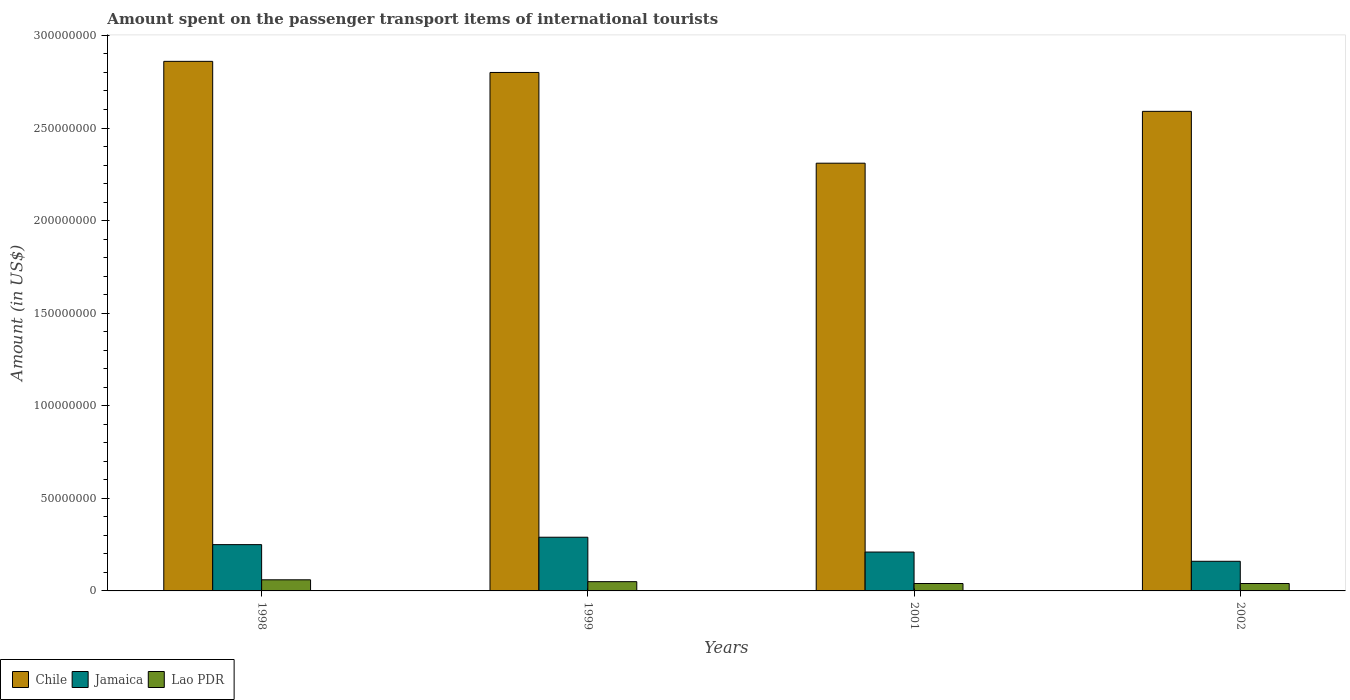How many groups of bars are there?
Your answer should be very brief. 4. How many bars are there on the 2nd tick from the left?
Your answer should be compact. 3. How many bars are there on the 1st tick from the right?
Offer a very short reply. 3. In how many cases, is the number of bars for a given year not equal to the number of legend labels?
Keep it short and to the point. 0. What is the amount spent on the passenger transport items of international tourists in Chile in 1999?
Your answer should be very brief. 2.80e+08. In which year was the amount spent on the passenger transport items of international tourists in Chile maximum?
Offer a terse response. 1998. What is the total amount spent on the passenger transport items of international tourists in Chile in the graph?
Make the answer very short. 1.06e+09. What is the difference between the amount spent on the passenger transport items of international tourists in Chile in 1999 and that in 2002?
Offer a terse response. 2.10e+07. What is the difference between the amount spent on the passenger transport items of international tourists in Lao PDR in 1998 and the amount spent on the passenger transport items of international tourists in Jamaica in 2001?
Provide a succinct answer. -1.50e+07. What is the average amount spent on the passenger transport items of international tourists in Jamaica per year?
Your response must be concise. 2.28e+07. In the year 2001, what is the difference between the amount spent on the passenger transport items of international tourists in Chile and amount spent on the passenger transport items of international tourists in Jamaica?
Your response must be concise. 2.10e+08. Is the difference between the amount spent on the passenger transport items of international tourists in Chile in 1998 and 2001 greater than the difference between the amount spent on the passenger transport items of international tourists in Jamaica in 1998 and 2001?
Provide a short and direct response. Yes. What is the difference between the highest and the lowest amount spent on the passenger transport items of international tourists in Jamaica?
Make the answer very short. 1.30e+07. Is the sum of the amount spent on the passenger transport items of international tourists in Jamaica in 1999 and 2002 greater than the maximum amount spent on the passenger transport items of international tourists in Chile across all years?
Make the answer very short. No. What does the 1st bar from the left in 2002 represents?
Offer a very short reply. Chile. What does the 2nd bar from the right in 2002 represents?
Offer a terse response. Jamaica. Is it the case that in every year, the sum of the amount spent on the passenger transport items of international tourists in Jamaica and amount spent on the passenger transport items of international tourists in Chile is greater than the amount spent on the passenger transport items of international tourists in Lao PDR?
Offer a very short reply. Yes. Are all the bars in the graph horizontal?
Give a very brief answer. No. How many years are there in the graph?
Provide a short and direct response. 4. Where does the legend appear in the graph?
Ensure brevity in your answer.  Bottom left. How many legend labels are there?
Give a very brief answer. 3. How are the legend labels stacked?
Your answer should be very brief. Horizontal. What is the title of the graph?
Provide a short and direct response. Amount spent on the passenger transport items of international tourists. Does "Russian Federation" appear as one of the legend labels in the graph?
Give a very brief answer. No. What is the label or title of the X-axis?
Keep it short and to the point. Years. What is the Amount (in US$) of Chile in 1998?
Offer a terse response. 2.86e+08. What is the Amount (in US$) of Jamaica in 1998?
Your response must be concise. 2.50e+07. What is the Amount (in US$) of Chile in 1999?
Ensure brevity in your answer.  2.80e+08. What is the Amount (in US$) of Jamaica in 1999?
Your response must be concise. 2.90e+07. What is the Amount (in US$) in Lao PDR in 1999?
Ensure brevity in your answer.  5.00e+06. What is the Amount (in US$) of Chile in 2001?
Ensure brevity in your answer.  2.31e+08. What is the Amount (in US$) in Jamaica in 2001?
Offer a very short reply. 2.10e+07. What is the Amount (in US$) in Lao PDR in 2001?
Provide a succinct answer. 4.00e+06. What is the Amount (in US$) of Chile in 2002?
Give a very brief answer. 2.59e+08. What is the Amount (in US$) in Jamaica in 2002?
Make the answer very short. 1.60e+07. What is the Amount (in US$) of Lao PDR in 2002?
Give a very brief answer. 4.00e+06. Across all years, what is the maximum Amount (in US$) of Chile?
Offer a very short reply. 2.86e+08. Across all years, what is the maximum Amount (in US$) of Jamaica?
Offer a terse response. 2.90e+07. Across all years, what is the minimum Amount (in US$) of Chile?
Provide a succinct answer. 2.31e+08. Across all years, what is the minimum Amount (in US$) in Jamaica?
Your response must be concise. 1.60e+07. What is the total Amount (in US$) in Chile in the graph?
Give a very brief answer. 1.06e+09. What is the total Amount (in US$) in Jamaica in the graph?
Keep it short and to the point. 9.10e+07. What is the total Amount (in US$) in Lao PDR in the graph?
Your answer should be very brief. 1.90e+07. What is the difference between the Amount (in US$) in Chile in 1998 and that in 1999?
Provide a short and direct response. 6.00e+06. What is the difference between the Amount (in US$) of Chile in 1998 and that in 2001?
Provide a short and direct response. 5.50e+07. What is the difference between the Amount (in US$) of Chile in 1998 and that in 2002?
Provide a succinct answer. 2.70e+07. What is the difference between the Amount (in US$) of Jamaica in 1998 and that in 2002?
Offer a terse response. 9.00e+06. What is the difference between the Amount (in US$) of Lao PDR in 1998 and that in 2002?
Your response must be concise. 2.00e+06. What is the difference between the Amount (in US$) of Chile in 1999 and that in 2001?
Make the answer very short. 4.90e+07. What is the difference between the Amount (in US$) of Lao PDR in 1999 and that in 2001?
Ensure brevity in your answer.  1.00e+06. What is the difference between the Amount (in US$) of Chile in 1999 and that in 2002?
Your answer should be compact. 2.10e+07. What is the difference between the Amount (in US$) in Jamaica in 1999 and that in 2002?
Your response must be concise. 1.30e+07. What is the difference between the Amount (in US$) in Chile in 2001 and that in 2002?
Your answer should be compact. -2.80e+07. What is the difference between the Amount (in US$) in Jamaica in 2001 and that in 2002?
Provide a succinct answer. 5.00e+06. What is the difference between the Amount (in US$) in Chile in 1998 and the Amount (in US$) in Jamaica in 1999?
Your answer should be compact. 2.57e+08. What is the difference between the Amount (in US$) of Chile in 1998 and the Amount (in US$) of Lao PDR in 1999?
Keep it short and to the point. 2.81e+08. What is the difference between the Amount (in US$) in Jamaica in 1998 and the Amount (in US$) in Lao PDR in 1999?
Your answer should be compact. 2.00e+07. What is the difference between the Amount (in US$) of Chile in 1998 and the Amount (in US$) of Jamaica in 2001?
Offer a very short reply. 2.65e+08. What is the difference between the Amount (in US$) of Chile in 1998 and the Amount (in US$) of Lao PDR in 2001?
Offer a very short reply. 2.82e+08. What is the difference between the Amount (in US$) in Jamaica in 1998 and the Amount (in US$) in Lao PDR in 2001?
Provide a succinct answer. 2.10e+07. What is the difference between the Amount (in US$) of Chile in 1998 and the Amount (in US$) of Jamaica in 2002?
Your response must be concise. 2.70e+08. What is the difference between the Amount (in US$) of Chile in 1998 and the Amount (in US$) of Lao PDR in 2002?
Provide a short and direct response. 2.82e+08. What is the difference between the Amount (in US$) in Jamaica in 1998 and the Amount (in US$) in Lao PDR in 2002?
Provide a short and direct response. 2.10e+07. What is the difference between the Amount (in US$) of Chile in 1999 and the Amount (in US$) of Jamaica in 2001?
Offer a very short reply. 2.59e+08. What is the difference between the Amount (in US$) in Chile in 1999 and the Amount (in US$) in Lao PDR in 2001?
Your answer should be compact. 2.76e+08. What is the difference between the Amount (in US$) of Jamaica in 1999 and the Amount (in US$) of Lao PDR in 2001?
Offer a terse response. 2.50e+07. What is the difference between the Amount (in US$) of Chile in 1999 and the Amount (in US$) of Jamaica in 2002?
Your answer should be very brief. 2.64e+08. What is the difference between the Amount (in US$) in Chile in 1999 and the Amount (in US$) in Lao PDR in 2002?
Provide a succinct answer. 2.76e+08. What is the difference between the Amount (in US$) in Jamaica in 1999 and the Amount (in US$) in Lao PDR in 2002?
Offer a terse response. 2.50e+07. What is the difference between the Amount (in US$) of Chile in 2001 and the Amount (in US$) of Jamaica in 2002?
Give a very brief answer. 2.15e+08. What is the difference between the Amount (in US$) of Chile in 2001 and the Amount (in US$) of Lao PDR in 2002?
Provide a short and direct response. 2.27e+08. What is the difference between the Amount (in US$) in Jamaica in 2001 and the Amount (in US$) in Lao PDR in 2002?
Make the answer very short. 1.70e+07. What is the average Amount (in US$) of Chile per year?
Give a very brief answer. 2.64e+08. What is the average Amount (in US$) of Jamaica per year?
Ensure brevity in your answer.  2.28e+07. What is the average Amount (in US$) in Lao PDR per year?
Keep it short and to the point. 4.75e+06. In the year 1998, what is the difference between the Amount (in US$) of Chile and Amount (in US$) of Jamaica?
Provide a succinct answer. 2.61e+08. In the year 1998, what is the difference between the Amount (in US$) in Chile and Amount (in US$) in Lao PDR?
Offer a very short reply. 2.80e+08. In the year 1998, what is the difference between the Amount (in US$) of Jamaica and Amount (in US$) of Lao PDR?
Keep it short and to the point. 1.90e+07. In the year 1999, what is the difference between the Amount (in US$) in Chile and Amount (in US$) in Jamaica?
Your answer should be very brief. 2.51e+08. In the year 1999, what is the difference between the Amount (in US$) in Chile and Amount (in US$) in Lao PDR?
Ensure brevity in your answer.  2.75e+08. In the year 1999, what is the difference between the Amount (in US$) of Jamaica and Amount (in US$) of Lao PDR?
Provide a succinct answer. 2.40e+07. In the year 2001, what is the difference between the Amount (in US$) of Chile and Amount (in US$) of Jamaica?
Your response must be concise. 2.10e+08. In the year 2001, what is the difference between the Amount (in US$) of Chile and Amount (in US$) of Lao PDR?
Your answer should be very brief. 2.27e+08. In the year 2001, what is the difference between the Amount (in US$) of Jamaica and Amount (in US$) of Lao PDR?
Give a very brief answer. 1.70e+07. In the year 2002, what is the difference between the Amount (in US$) of Chile and Amount (in US$) of Jamaica?
Your answer should be very brief. 2.43e+08. In the year 2002, what is the difference between the Amount (in US$) of Chile and Amount (in US$) of Lao PDR?
Give a very brief answer. 2.55e+08. In the year 2002, what is the difference between the Amount (in US$) in Jamaica and Amount (in US$) in Lao PDR?
Your answer should be very brief. 1.20e+07. What is the ratio of the Amount (in US$) in Chile in 1998 to that in 1999?
Your answer should be compact. 1.02. What is the ratio of the Amount (in US$) in Jamaica in 1998 to that in 1999?
Your answer should be very brief. 0.86. What is the ratio of the Amount (in US$) in Chile in 1998 to that in 2001?
Give a very brief answer. 1.24. What is the ratio of the Amount (in US$) of Jamaica in 1998 to that in 2001?
Give a very brief answer. 1.19. What is the ratio of the Amount (in US$) in Lao PDR in 1998 to that in 2001?
Make the answer very short. 1.5. What is the ratio of the Amount (in US$) of Chile in 1998 to that in 2002?
Your answer should be very brief. 1.1. What is the ratio of the Amount (in US$) in Jamaica in 1998 to that in 2002?
Provide a short and direct response. 1.56. What is the ratio of the Amount (in US$) of Lao PDR in 1998 to that in 2002?
Offer a terse response. 1.5. What is the ratio of the Amount (in US$) in Chile in 1999 to that in 2001?
Provide a succinct answer. 1.21. What is the ratio of the Amount (in US$) of Jamaica in 1999 to that in 2001?
Your response must be concise. 1.38. What is the ratio of the Amount (in US$) in Chile in 1999 to that in 2002?
Make the answer very short. 1.08. What is the ratio of the Amount (in US$) of Jamaica in 1999 to that in 2002?
Provide a succinct answer. 1.81. What is the ratio of the Amount (in US$) of Lao PDR in 1999 to that in 2002?
Provide a short and direct response. 1.25. What is the ratio of the Amount (in US$) of Chile in 2001 to that in 2002?
Your answer should be compact. 0.89. What is the ratio of the Amount (in US$) of Jamaica in 2001 to that in 2002?
Your answer should be compact. 1.31. What is the ratio of the Amount (in US$) of Lao PDR in 2001 to that in 2002?
Offer a very short reply. 1. What is the difference between the highest and the second highest Amount (in US$) of Jamaica?
Give a very brief answer. 4.00e+06. What is the difference between the highest and the lowest Amount (in US$) of Chile?
Give a very brief answer. 5.50e+07. What is the difference between the highest and the lowest Amount (in US$) in Jamaica?
Give a very brief answer. 1.30e+07. 